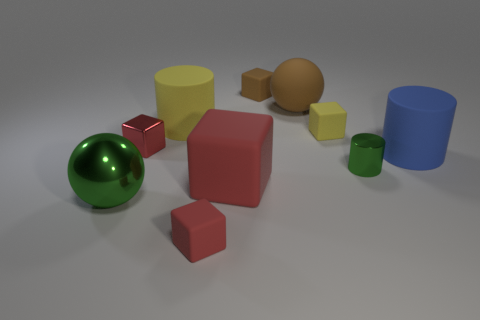Subtract all rubber cylinders. How many cylinders are left? 1 Subtract all purple cylinders. How many red blocks are left? 3 Subtract all brown balls. How many balls are left? 1 Subtract 3 blocks. How many blocks are left? 2 Subtract all big gray matte balls. Subtract all large red rubber objects. How many objects are left? 9 Add 1 large blue cylinders. How many large blue cylinders are left? 2 Add 3 yellow cylinders. How many yellow cylinders exist? 4 Subtract 0 gray cylinders. How many objects are left? 10 Subtract all cylinders. How many objects are left? 7 Subtract all yellow cylinders. Subtract all brown cubes. How many cylinders are left? 2 